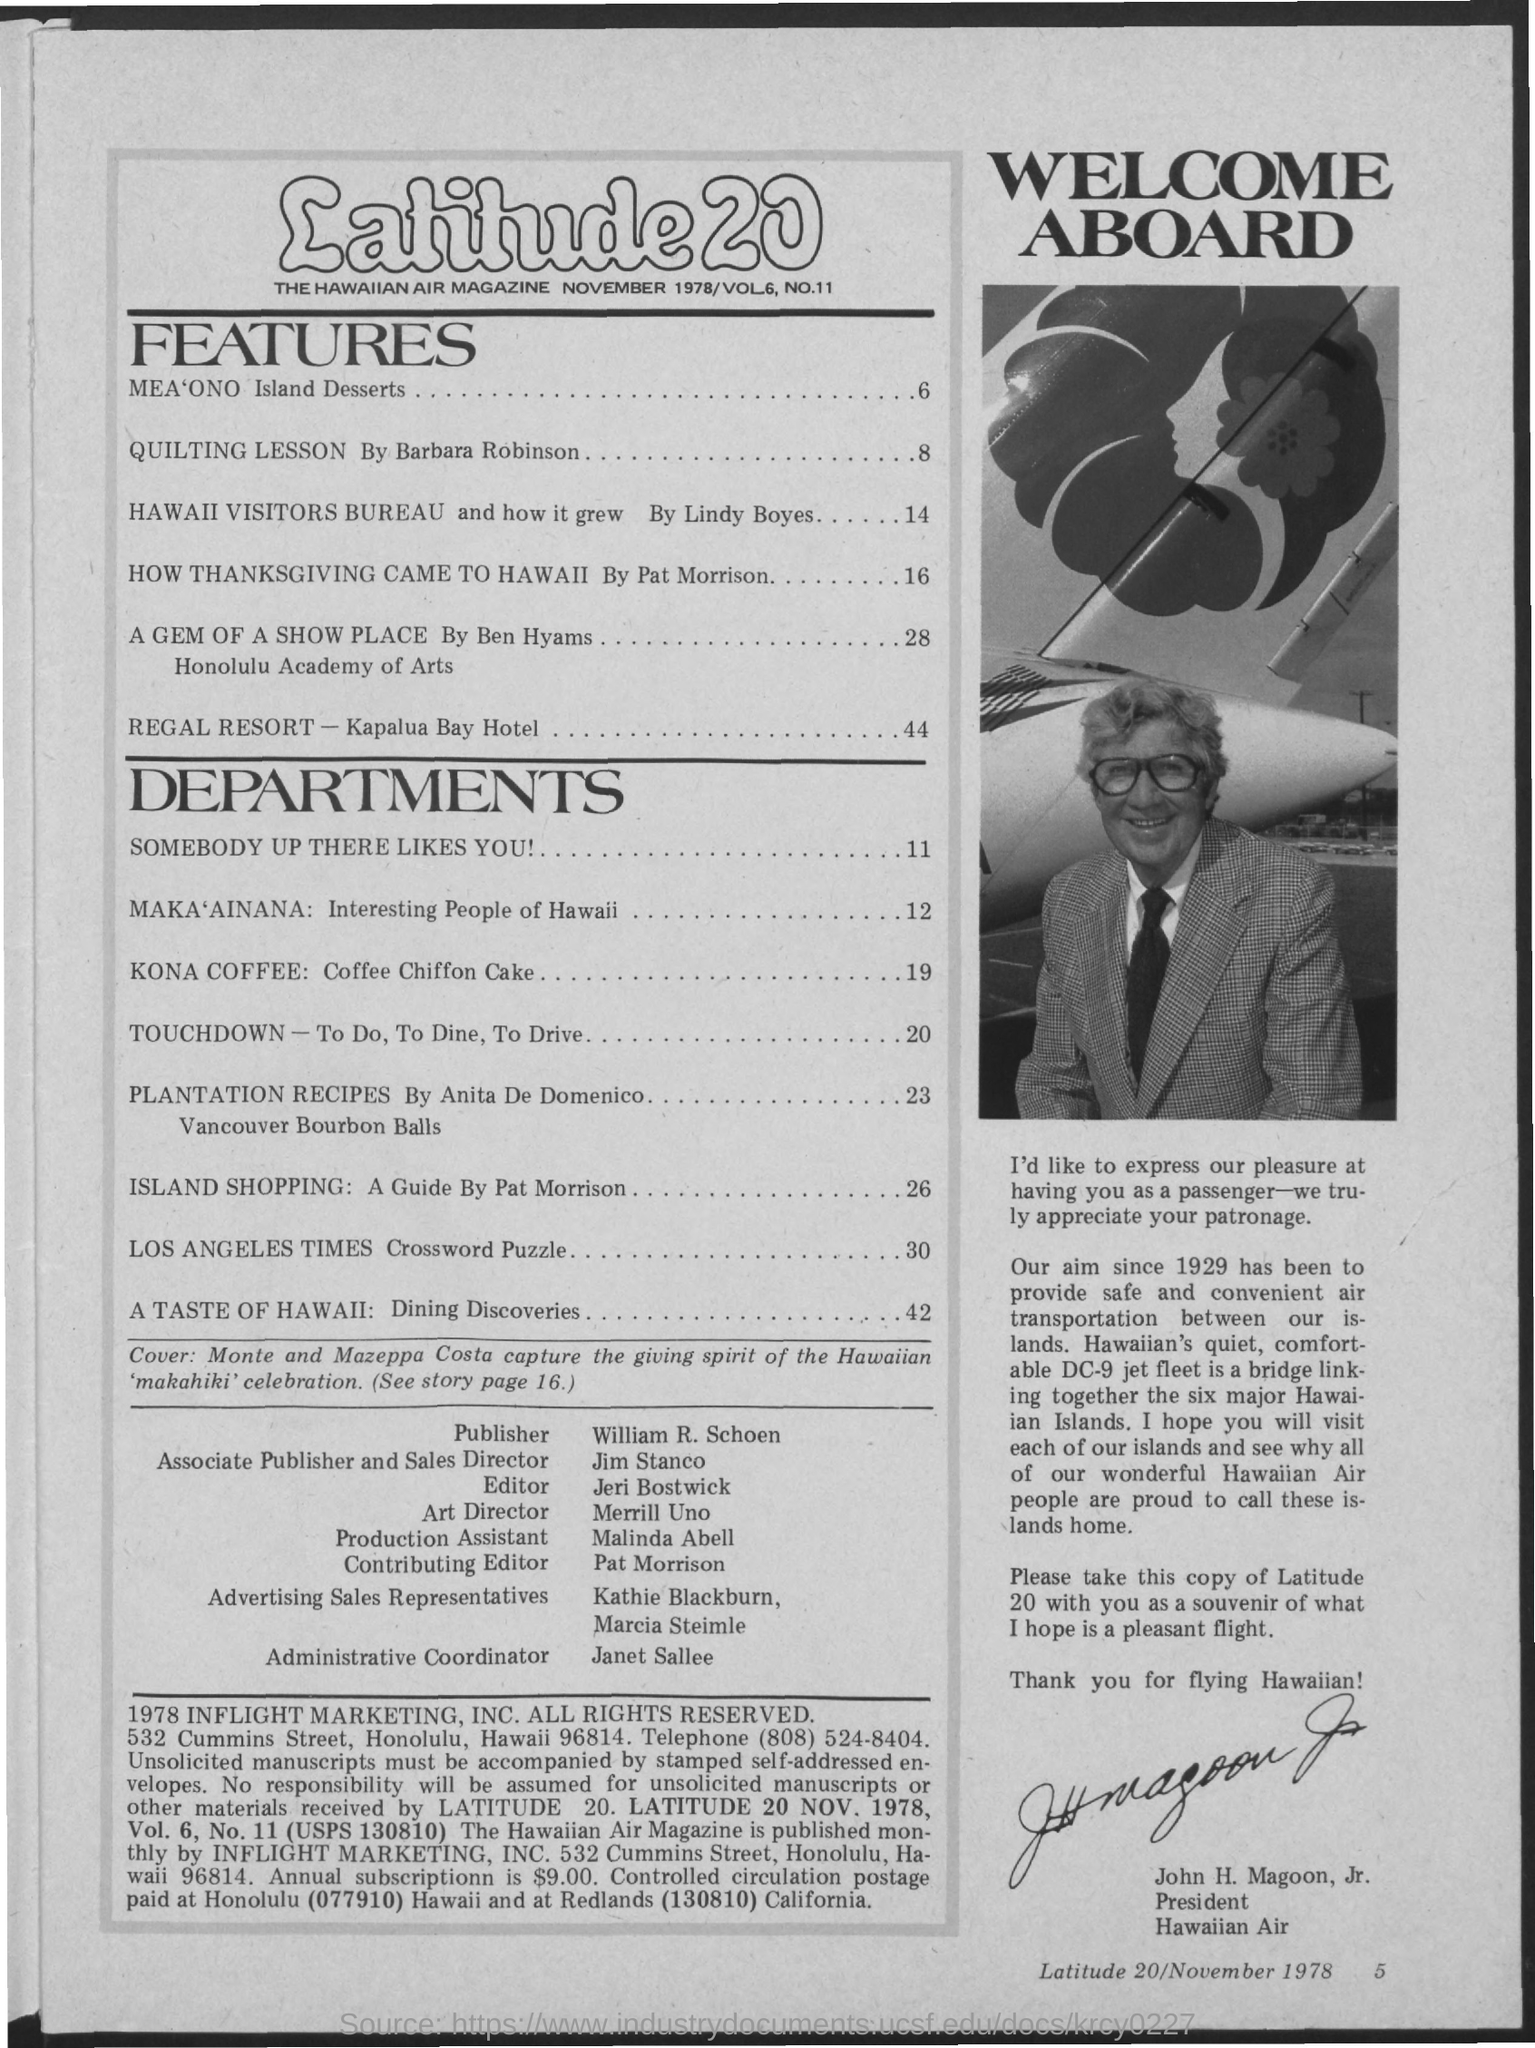Indicate a few pertinent items in this graphic. The page number of "A Gem of a Show Place" is 28. The name of the air magazine is Latitude 20.. Janet Sallee is the Administrative Coordinator. QUILTING LESSON, a novel written by Barbara Robinson, was published. The publisher of the magazine is William. 